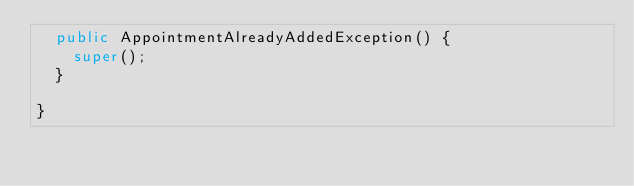<code> <loc_0><loc_0><loc_500><loc_500><_Java_>	public AppointmentAlreadyAddedException() {
		super();
	}
	
}
</code> 